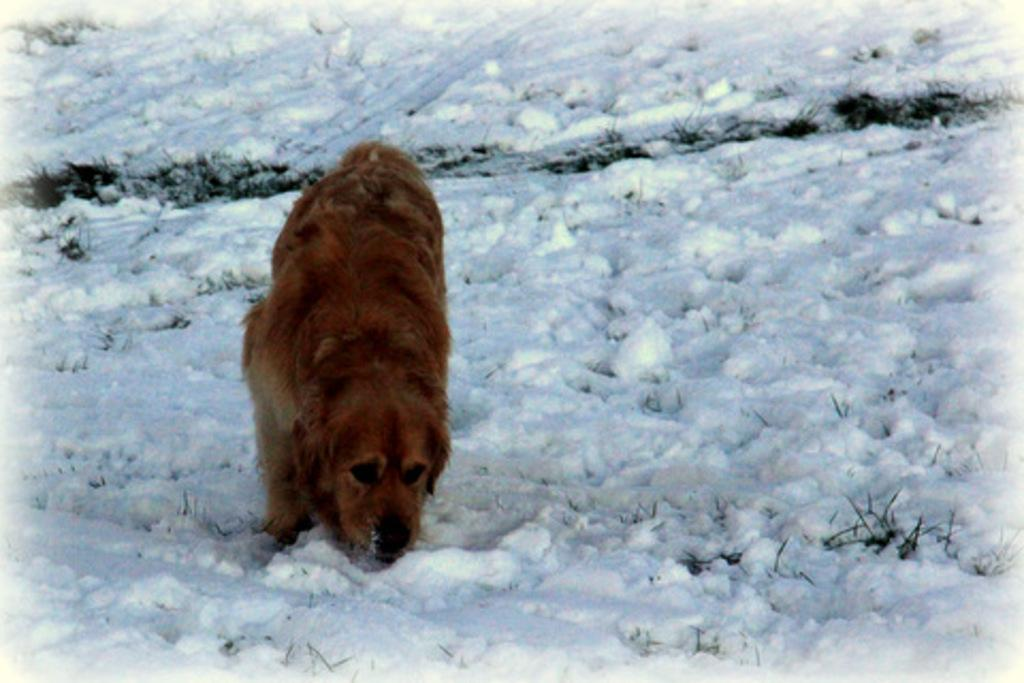What type of animal can be seen in the image? There is an animal in the image, but its specific type cannot be determined from the provided facts. Where is the animal located in the image? The animal is on the ground in the image. What is the background of the image? There is snow visible in the background of the image. What type of haircut does the animal have in the image? There is no information about the animal's haircut in the image, as the focus is on its location and the snowy background. 